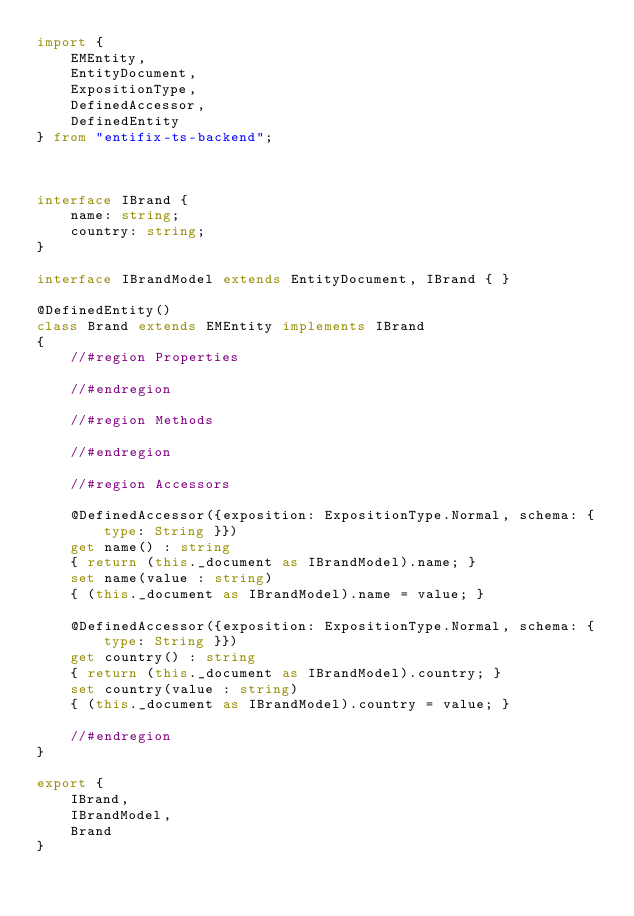<code> <loc_0><loc_0><loc_500><loc_500><_TypeScript_>import { 
    EMEntity, 
    EntityDocument, 
    ExpositionType,
    DefinedAccessor,
    DefinedEntity
} from "entifix-ts-backend";



interface IBrand {
    name: string;
    country: string;
}

interface IBrandModel extends EntityDocument, IBrand { }

@DefinedEntity()
class Brand extends EMEntity implements IBrand
{
    //#region Properties

    //#endregion

    //#region Methods
   
    //#endregion

    //#region Accessors

    @DefinedAccessor({exposition: ExpositionType.Normal, schema: { type: String }})
    get name() : string
    { return (this._document as IBrandModel).name; }
    set name(value : string)
    { (this._document as IBrandModel).name = value; }

    @DefinedAccessor({exposition: ExpositionType.Normal, schema: { type: String }})
    get country() : string
    { return (this._document as IBrandModel).country; }
    set country(value : string)
    { (this._document as IBrandModel).country = value; }

    //#endregion
}

export {
    IBrand,
    IBrandModel,
    Brand
}</code> 